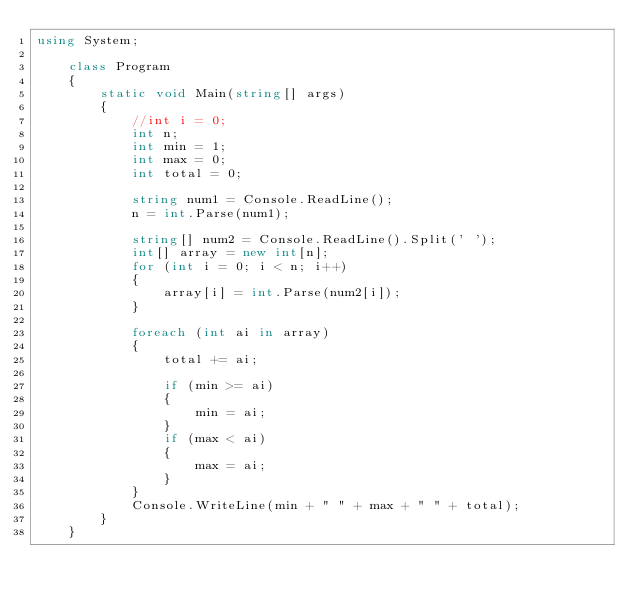Convert code to text. <code><loc_0><loc_0><loc_500><loc_500><_C#_>using System;

    class Program
    {
        static void Main(string[] args)
        {
            //int i = 0;
            int n;
            int min = 1;
            int max = 0;
            int total = 0;

            string num1 = Console.ReadLine();
            n = int.Parse(num1);

            string[] num2 = Console.ReadLine().Split(' ');
            int[] array = new int[n];
            for (int i = 0; i < n; i++)
            {
                array[i] = int.Parse(num2[i]);
            }
            
            foreach (int ai in array)
            {
                total += ai;

                if (min >= ai)
                {
                    min = ai;
                }
                if (max < ai)
                {
                    max = ai;
                }
            }
            Console.WriteLine(min + " " + max + " " + total);
        }
    }

</code> 